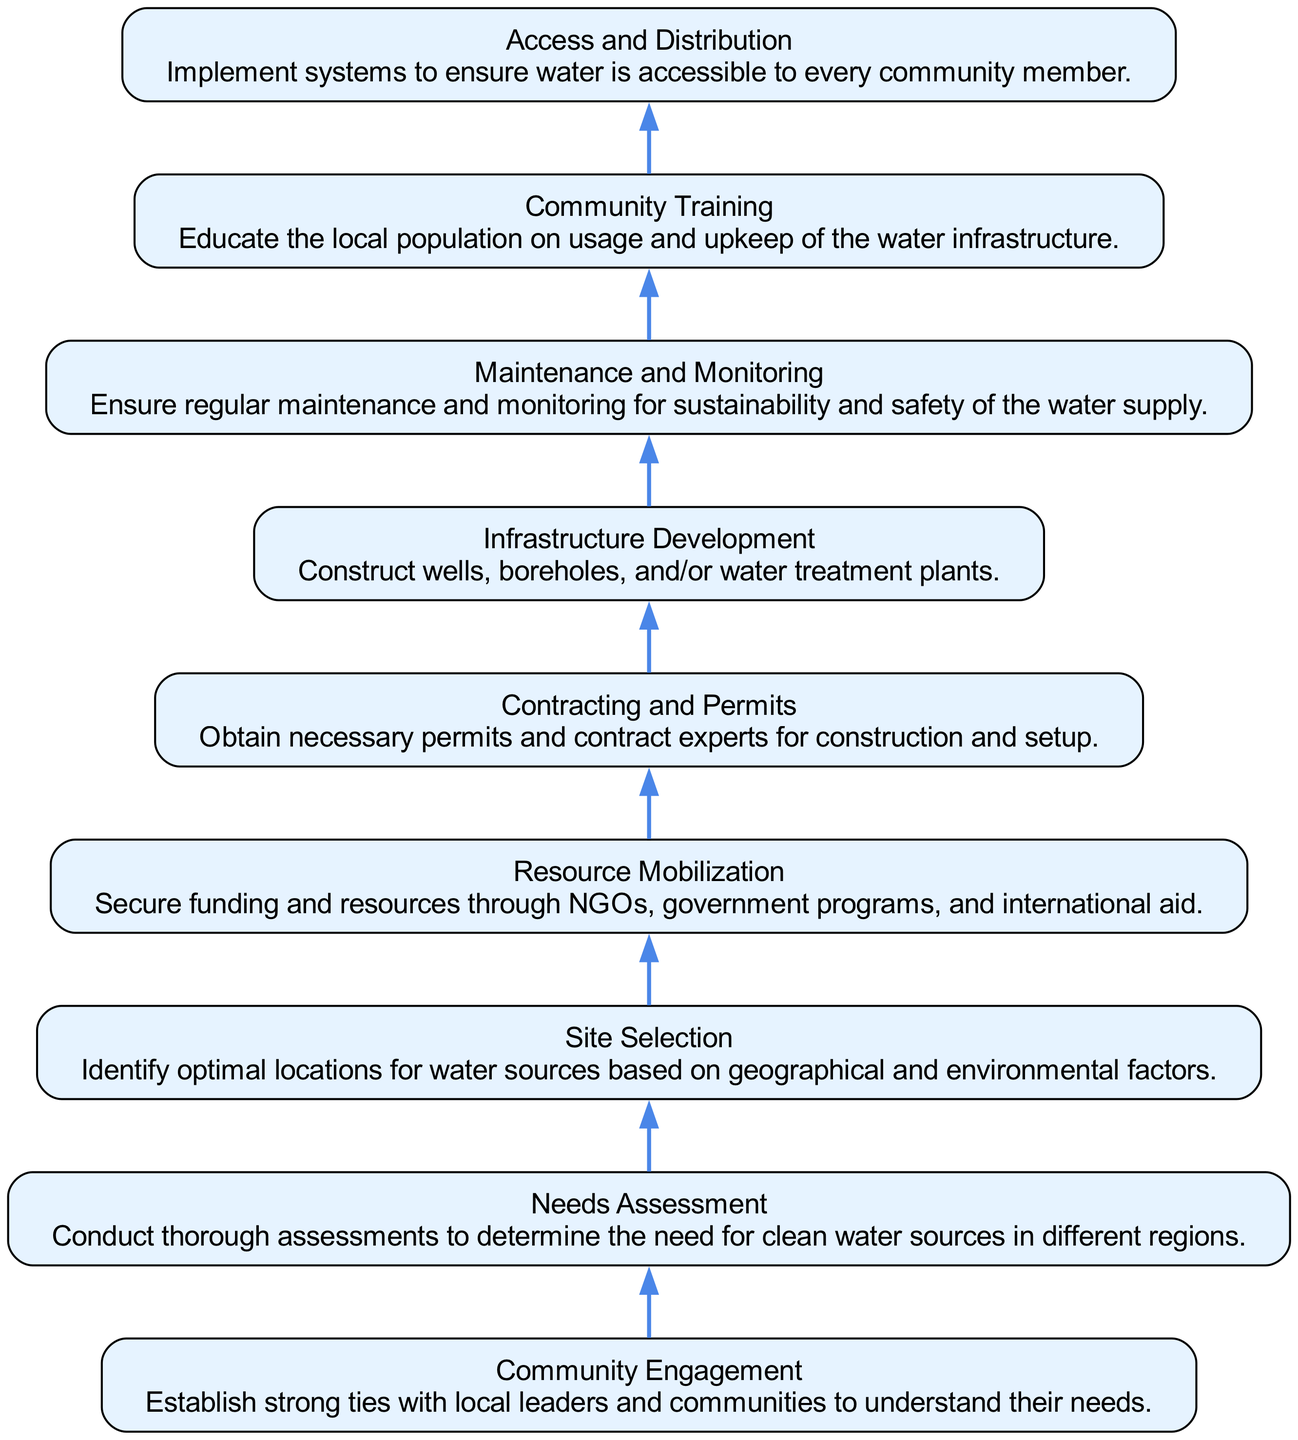What is the first step in the flow? The first step in the flow chart is "Community Engagement," which establishes ties with local leaders and communities.
Answer: Community Engagement How many nodes are present in the diagram? By counting the distinct items in the flow chart, we find there are nine nodes, each representing a specific step in developing clean water infrastructure.
Answer: 9 What is the last step in the flow? The last step in the flow chart is "Maintenance and Monitoring," which ensures sustainability and safety of the water supply.
Answer: Maintenance and Monitoring Which step follows "Site Selection"? After "Site Selection," the next step in the flow is "Resource Mobilization," indicating that once a site is selected, resources are needed.
Answer: Resource Mobilization What is the relationship between "Community Training" and "Access and Distribution"? "Community Training" comes before "Access and Distribution," implying that the community needs training on usage and upkeep before they can access the water.
Answer: Community Training → Access and Distribution What step immediately precedes "Infrastructure Development"? "Contracting and Permits" is the step that immediately precedes "Infrastructure Development," as securing permits is necessary for construction.
Answer: Contracting and Permits How does "Community Engagement" influence subsequent steps? "Community Engagement" is the starting point that informs the "Needs Assessment," ensuring that the needs of the community are understood and addressed in the following steps.
Answer: It informs the Needs Assessment What are the two final steps in the flow? The two final steps are "Access and Distribution" and "Maintenance and Monitoring," highlighting the importance of both providing access to water and ensuring ongoing support.
Answer: Access and Distribution, Maintenance and Monitoring Which step focuses on funding and resource acquisition? The step that focuses on funding and resource acquisition is "Resource Mobilization," indicating its importance in the overall process.
Answer: Resource Mobilization 